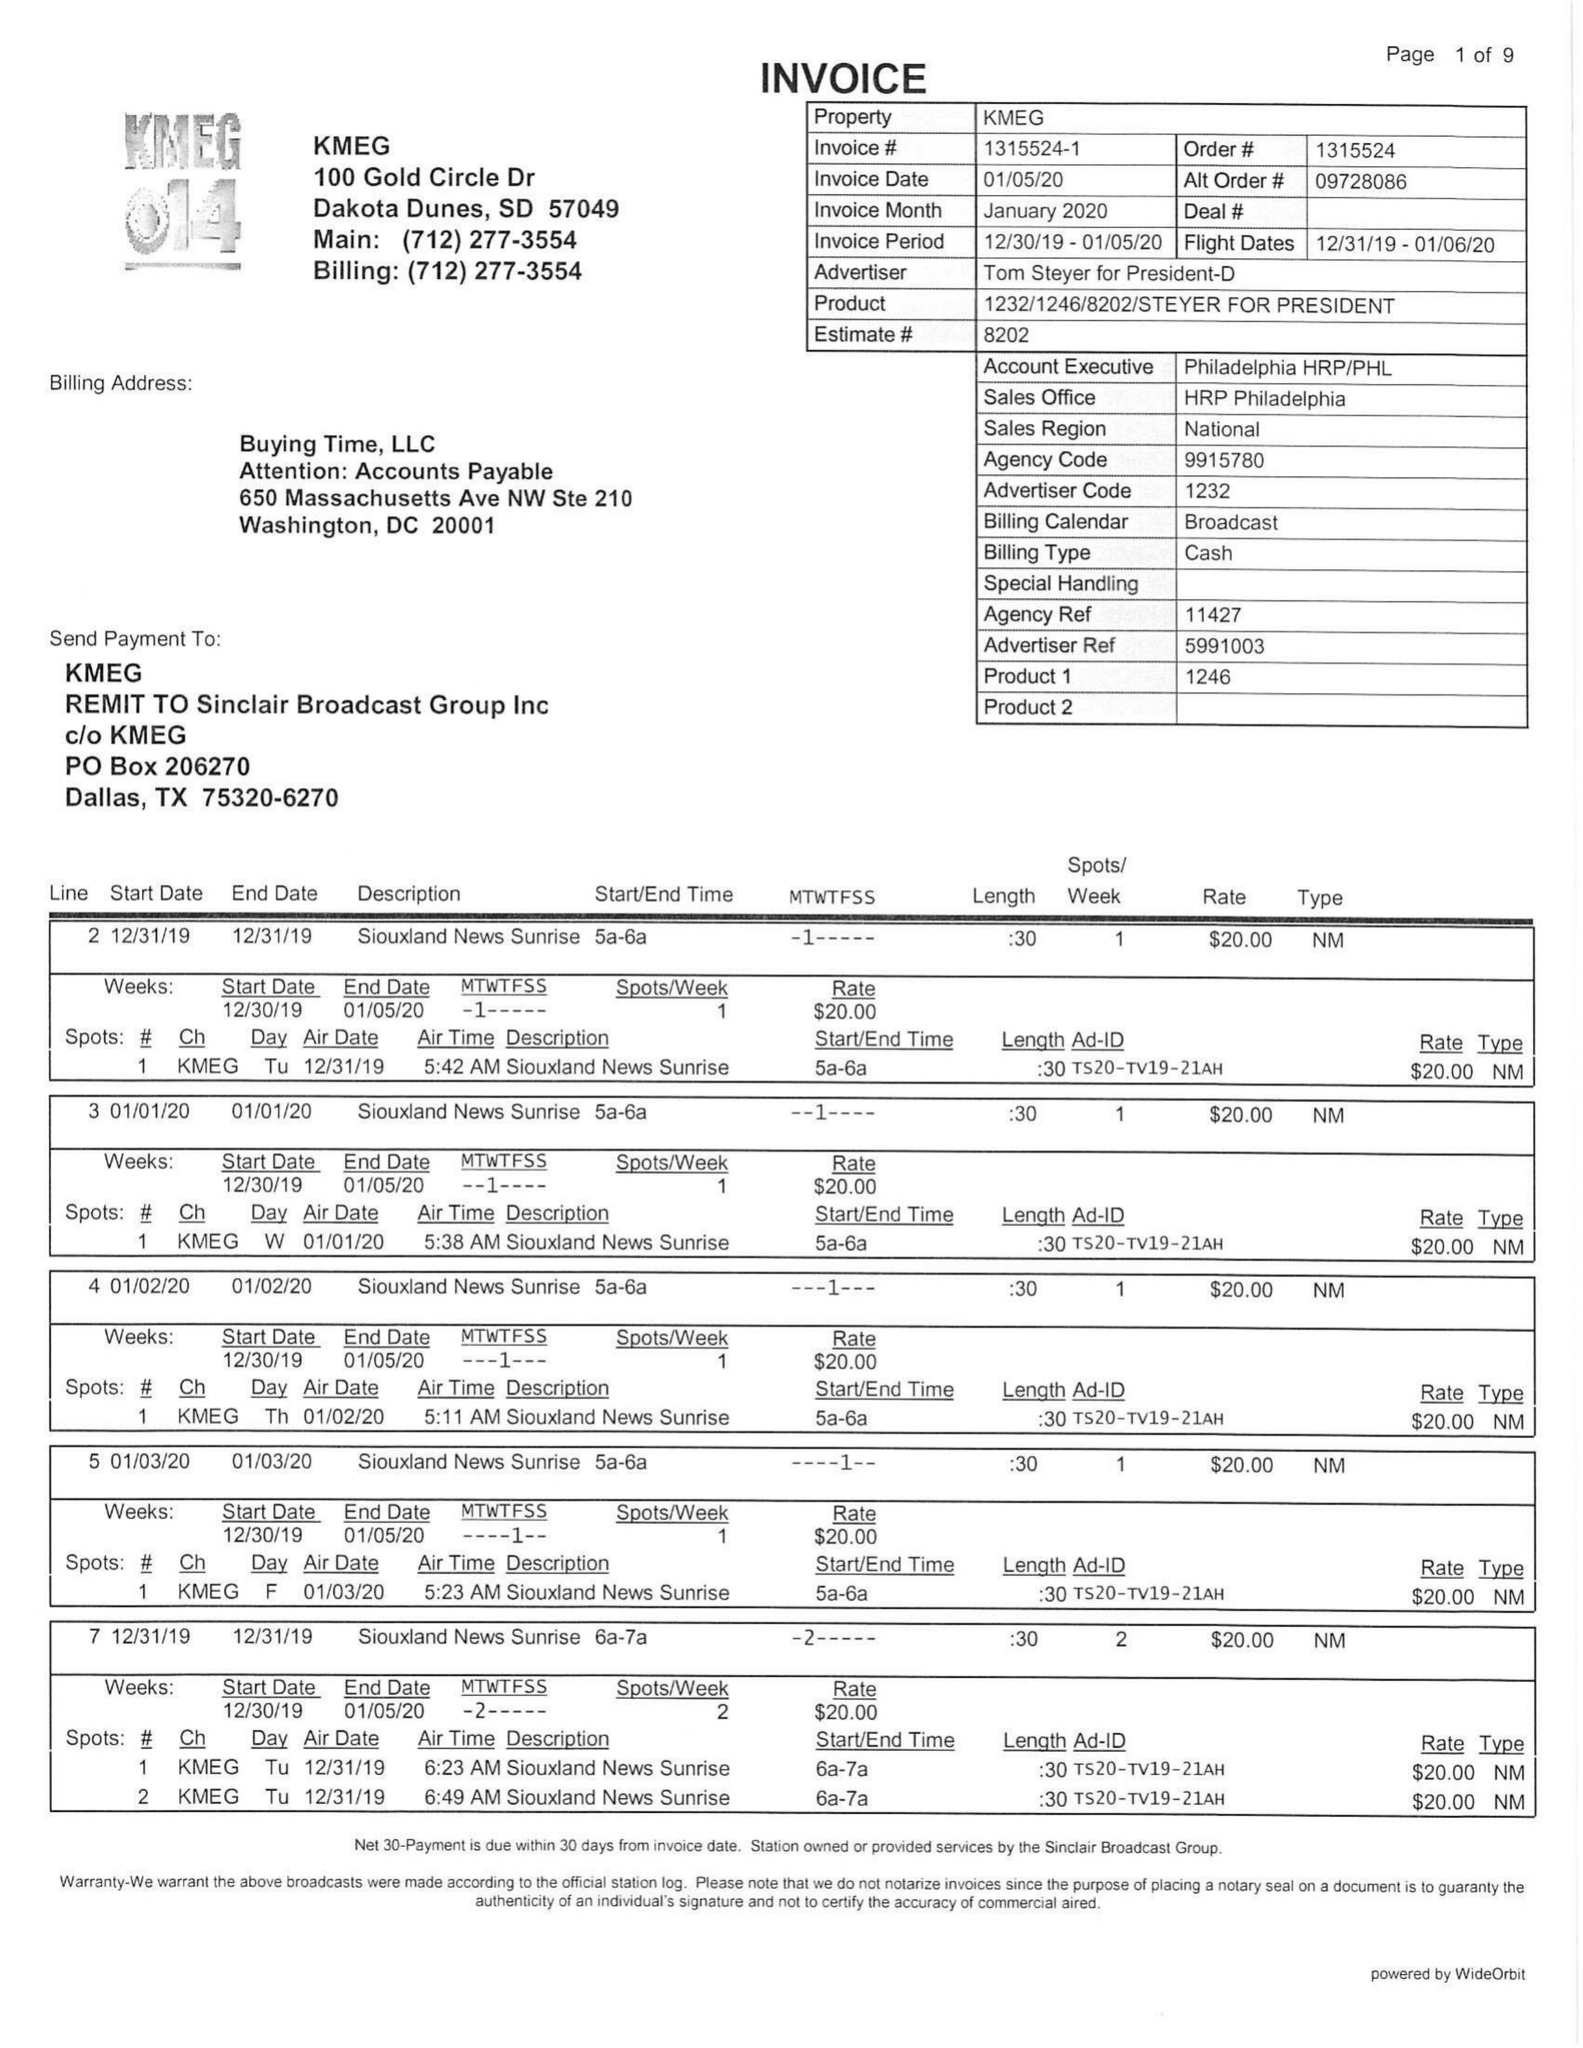What is the value for the contract_num?
Answer the question using a single word or phrase. 1315524 